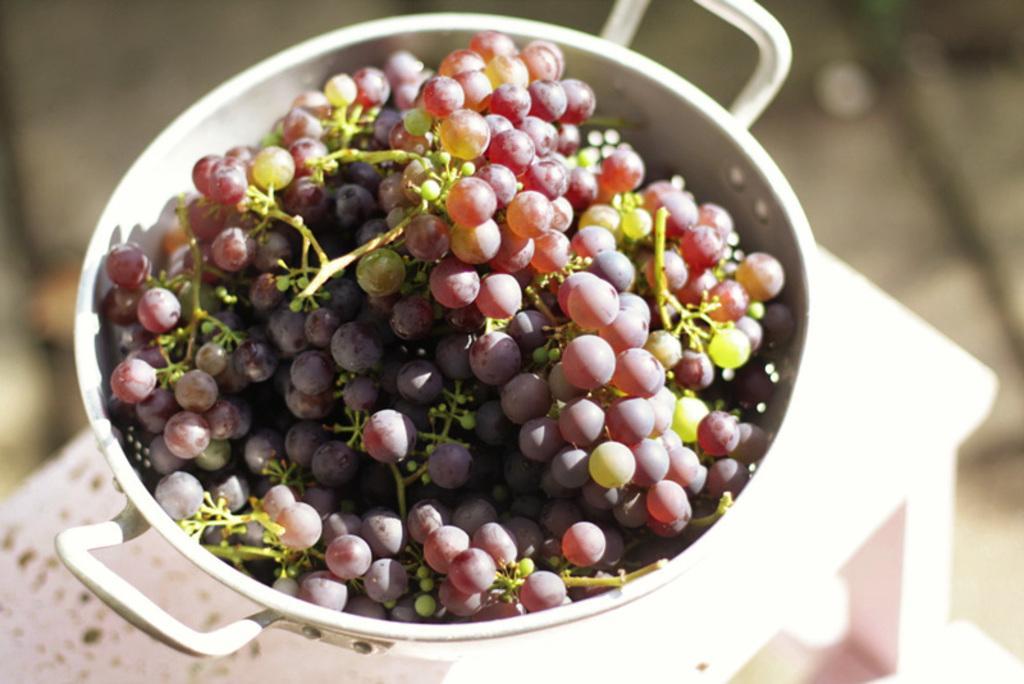How would you summarize this image in a sentence or two? In the image I can see the table, At the top of the table I can one bowl of grapes. The background of the image is blurred. 